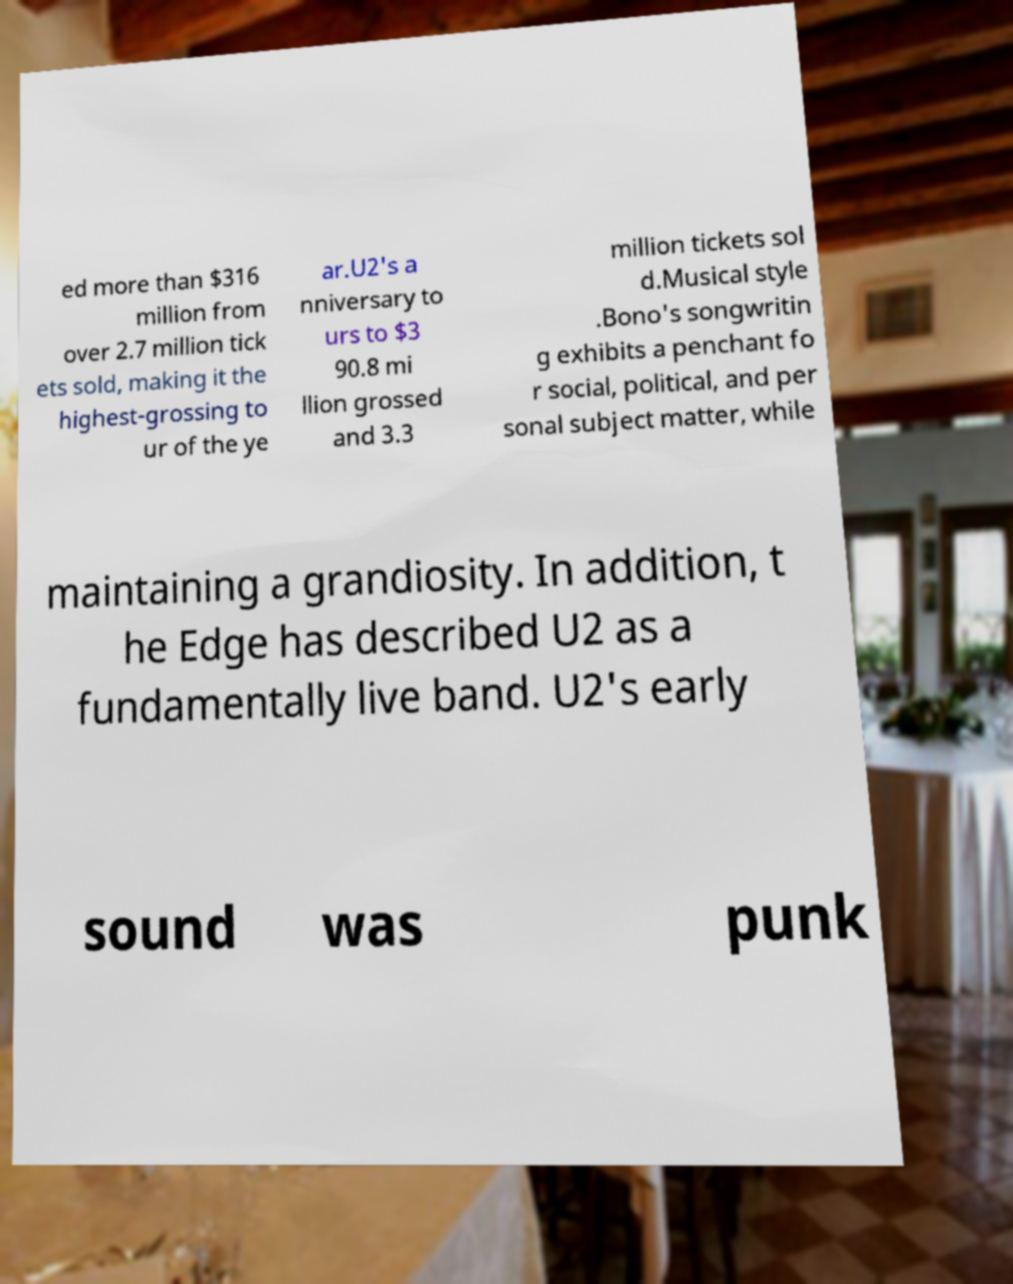Please identify and transcribe the text found in this image. ed more than $316 million from over 2.7 million tick ets sold, making it the highest-grossing to ur of the ye ar.U2's a nniversary to urs to $3 90.8 mi llion grossed and 3.3 million tickets sol d.Musical style .Bono's songwritin g exhibits a penchant fo r social, political, and per sonal subject matter, while maintaining a grandiosity. In addition, t he Edge has described U2 as a fundamentally live band. U2's early sound was punk 